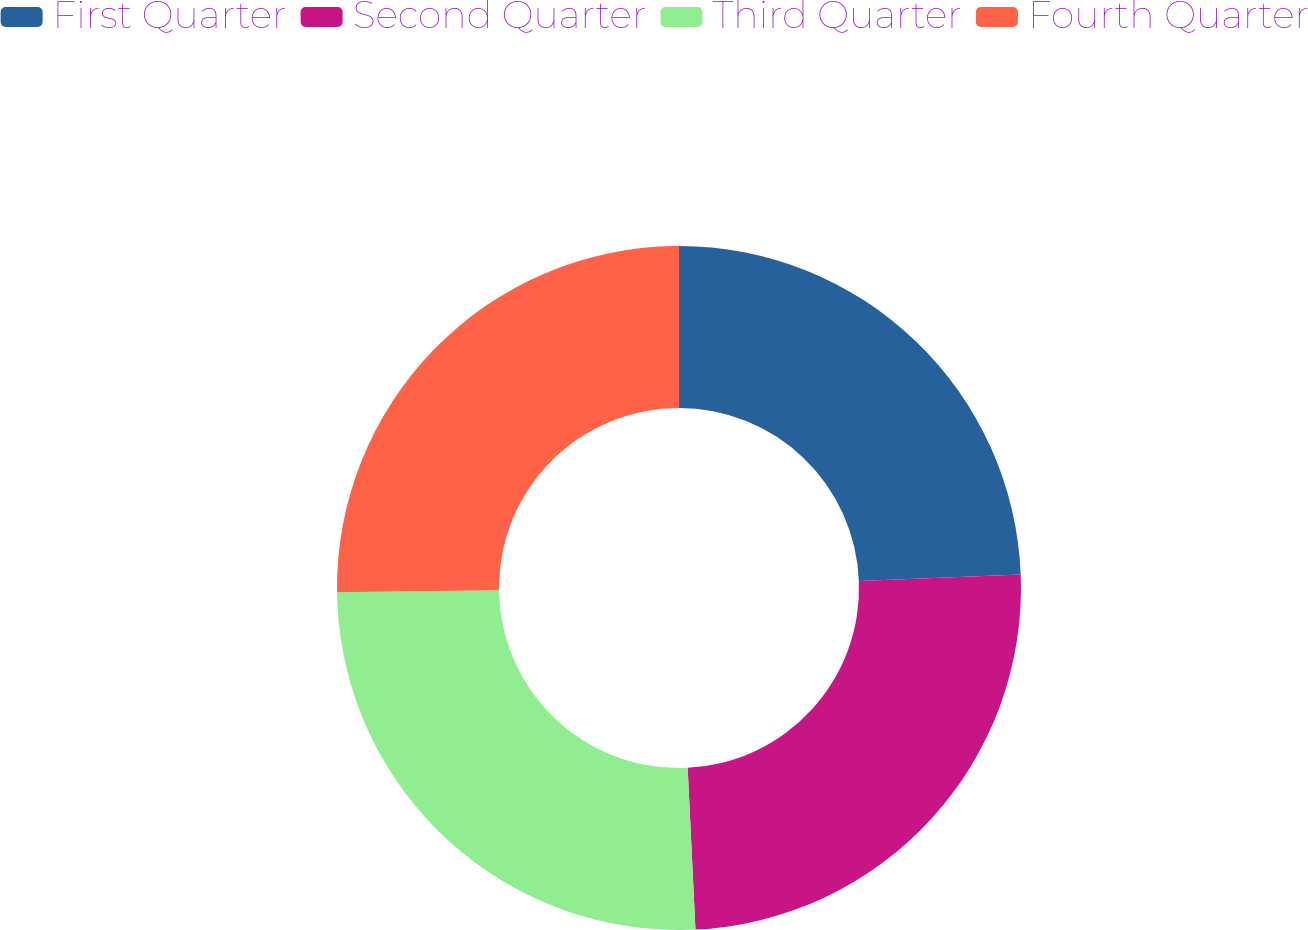Convert chart. <chart><loc_0><loc_0><loc_500><loc_500><pie_chart><fcel>First Quarter<fcel>Second Quarter<fcel>Third Quarter<fcel>Fourth Quarter<nl><fcel>24.37%<fcel>24.86%<fcel>25.56%<fcel>25.2%<nl></chart> 